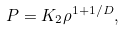<formula> <loc_0><loc_0><loc_500><loc_500>P = K _ { 2 } \rho ^ { 1 + { 1 / D } } ,</formula> 